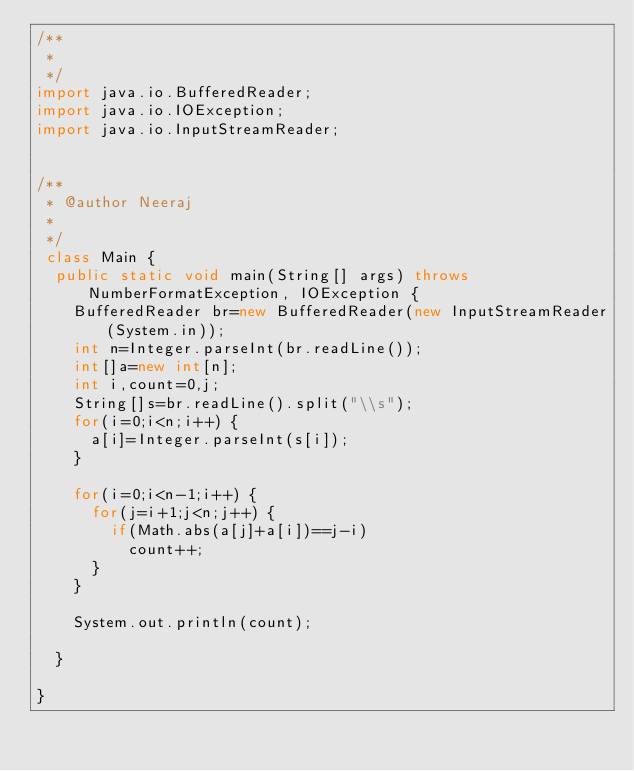Convert code to text. <code><loc_0><loc_0><loc_500><loc_500><_Java_>/**
 * 
 */
import java.io.BufferedReader;
import java.io.IOException;
import java.io.InputStreamReader;


/**
 * @author Neeraj
 *
 */
 class Main {
	public static void main(String[] args) throws NumberFormatException, IOException {
		BufferedReader br=new BufferedReader(new InputStreamReader(System.in));
		int n=Integer.parseInt(br.readLine());
		int[]a=new int[n];
		int i,count=0,j;
		String[]s=br.readLine().split("\\s");
		for(i=0;i<n;i++) {
			a[i]=Integer.parseInt(s[i]);
		}
		
		for(i=0;i<n-1;i++) {
			for(j=i+1;j<n;j++) {
				if(Math.abs(a[j]+a[i])==j-i)
					count++;
			}
		}
		
		System.out.println(count);
		
	}

}
</code> 